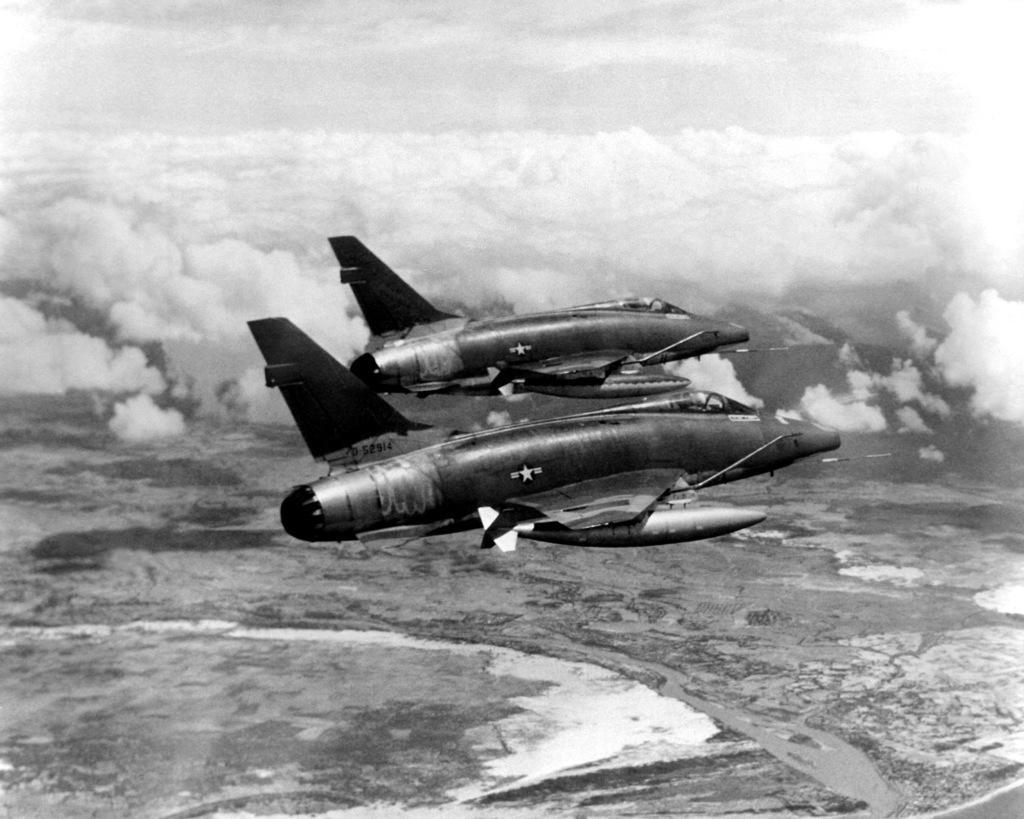Can you describe this image briefly? In this image I can see two airplanes are flying in the air. Here I can see clouds and sky. This image is black and white in color. 